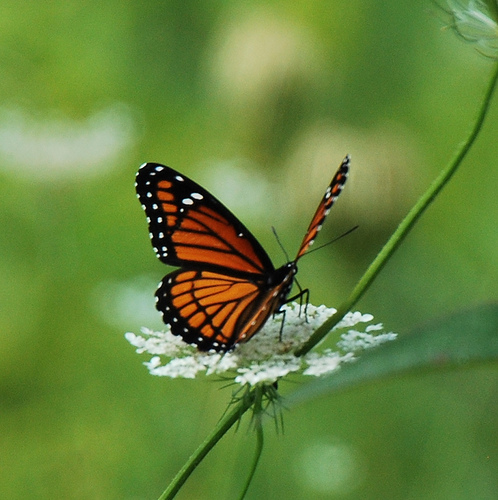<image>
Is the butterfly on the flower? Yes. Looking at the image, I can see the butterfly is positioned on top of the flower, with the flower providing support. Is the butterfly on the stem? Yes. Looking at the image, I can see the butterfly is positioned on top of the stem, with the stem providing support. Is there a butterfly under the flower? No. The butterfly is not positioned under the flower. The vertical relationship between these objects is different. 